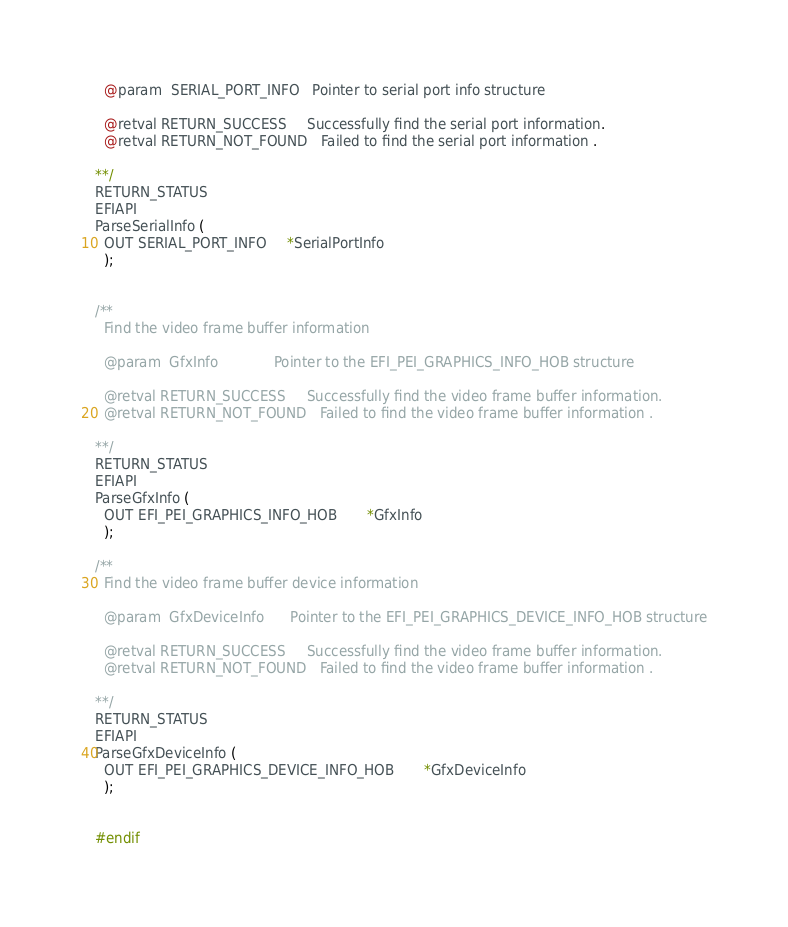Convert code to text. <code><loc_0><loc_0><loc_500><loc_500><_C_>
  @param  SERIAL_PORT_INFO   Pointer to serial port info structure

  @retval RETURN_SUCCESS     Successfully find the serial port information.
  @retval RETURN_NOT_FOUND   Failed to find the serial port information .

**/
RETURN_STATUS
EFIAPI
ParseSerialInfo (
  OUT SERIAL_PORT_INFO     *SerialPortInfo
  );


/**
  Find the video frame buffer information

  @param  GfxInfo             Pointer to the EFI_PEI_GRAPHICS_INFO_HOB structure

  @retval RETURN_SUCCESS     Successfully find the video frame buffer information.
  @retval RETURN_NOT_FOUND   Failed to find the video frame buffer information .

**/
RETURN_STATUS
EFIAPI
ParseGfxInfo (
  OUT EFI_PEI_GRAPHICS_INFO_HOB       *GfxInfo
  );

/**
  Find the video frame buffer device information

  @param  GfxDeviceInfo      Pointer to the EFI_PEI_GRAPHICS_DEVICE_INFO_HOB structure

  @retval RETURN_SUCCESS     Successfully find the video frame buffer information.
  @retval RETURN_NOT_FOUND   Failed to find the video frame buffer information .

**/
RETURN_STATUS
EFIAPI
ParseGfxDeviceInfo (
  OUT EFI_PEI_GRAPHICS_DEVICE_INFO_HOB       *GfxDeviceInfo
  );


#endif
</code> 